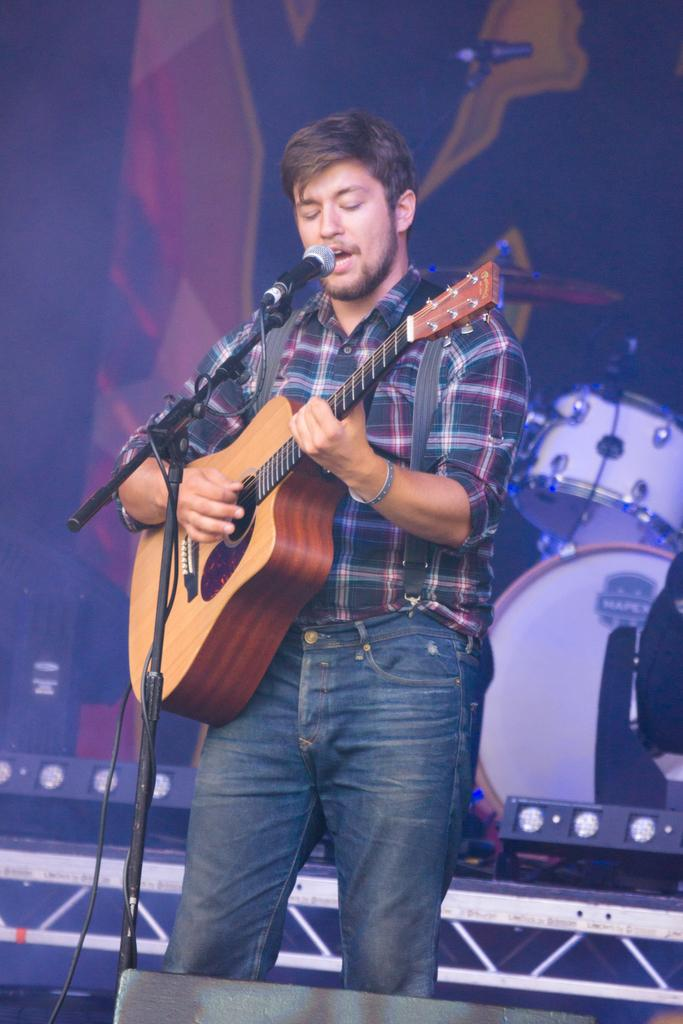Who is present in the image? There is a man in the image. What is the man doing in the image? The man is standing in the image. What object is the man holding in the image? The man is holding a guitar in the image. What object is in front of the man in the image? There is a microphone in front of the man in the image. What other musical instrument can be seen in the background of the image? There is a drum set in the background of the image. What type of sack is the man carrying on his back in the image? There is no sack present in the image; the man is holding a guitar and standing near a microphone and drum set. 